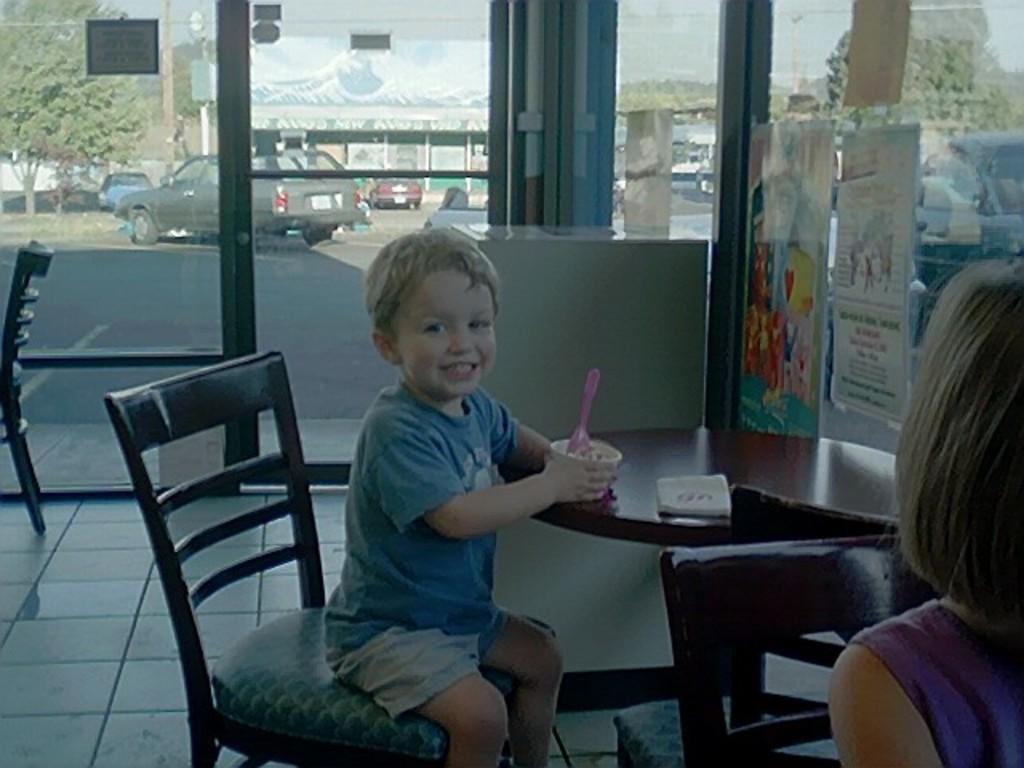Can you describe this image briefly? This is the picture of a small boy sitting on a chair holding a cup of ice cream. There is a table and to the ride side of the image we can a person and this picture is taken in a room with glass doors. There are some posters attached to the glass wall and we can see vehicles on the road, building and trees. 